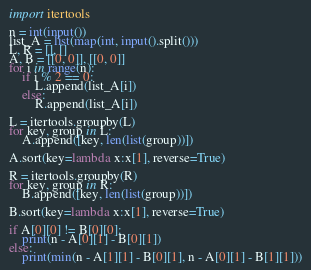<code> <loc_0><loc_0><loc_500><loc_500><_Python_>import itertools

n = int(input())
list_A = list(map(int, input().split()))
L, R = [], []
A, B = [[0, 0]], [[0, 0]]
for i in range(n):
    if i % 2 == 0:
        L.append(list_A[i])
    else:
        R.append(list_A[i])

L = itertools.groupby(L)
for key, group in L:
    A.append([key, len(list(group))])

A.sort(key=lambda x:x[1], reverse=True)

R = itertools.groupby(R)
for key, group in R:
    B.append([key, len(list(group))])

B.sort(key=lambda x:x[1], reverse=True)

if A[0][0] != B[0][0]:
    print(n - A[0][1] - B[0][1])
else:
    print(min(n - A[1][1] - B[0][1], n - A[0][1] - B[1][1]))</code> 